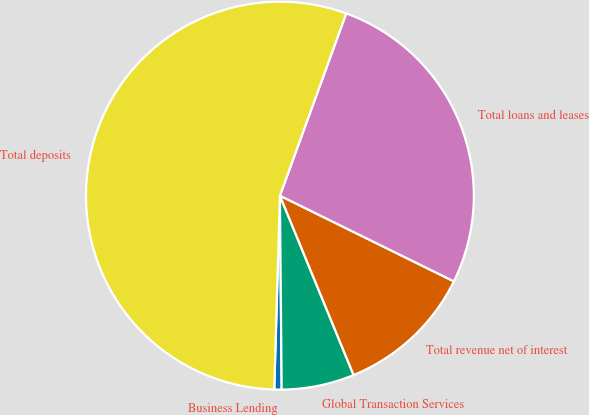Convert chart to OTSL. <chart><loc_0><loc_0><loc_500><loc_500><pie_chart><fcel>Business Lending<fcel>Global Transaction Services<fcel>Total revenue net of interest<fcel>Total loans and leases<fcel>Total deposits<nl><fcel>0.61%<fcel>6.06%<fcel>11.51%<fcel>26.73%<fcel>55.09%<nl></chart> 